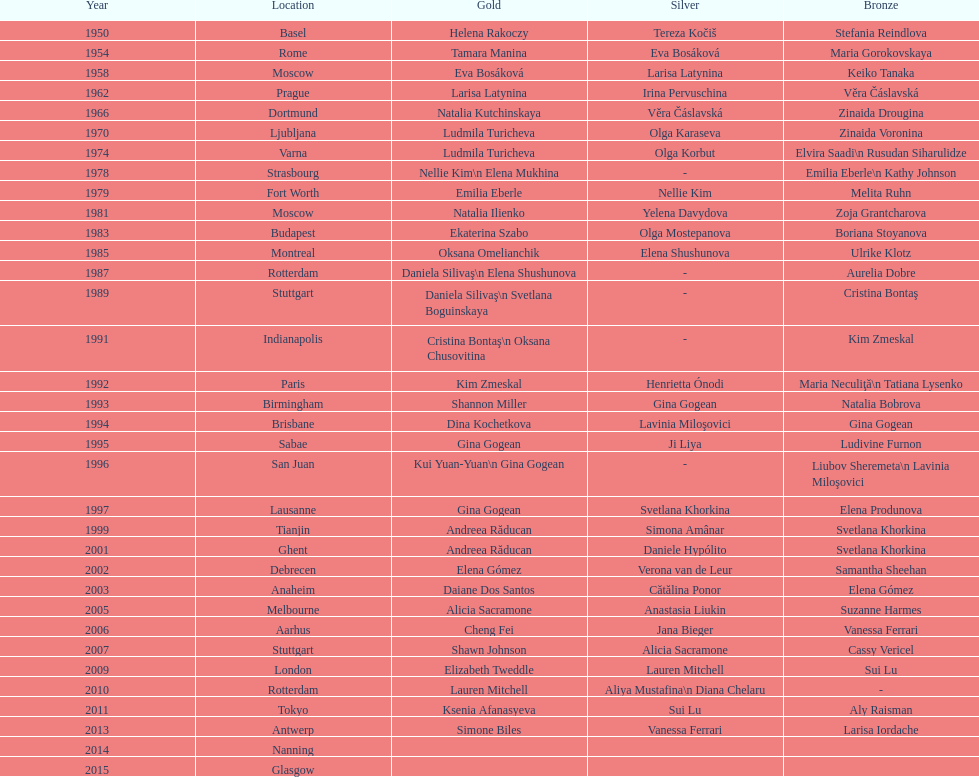As of 2013, what is the total number of floor exercise gold medals won by american women at the world championships? 5. 